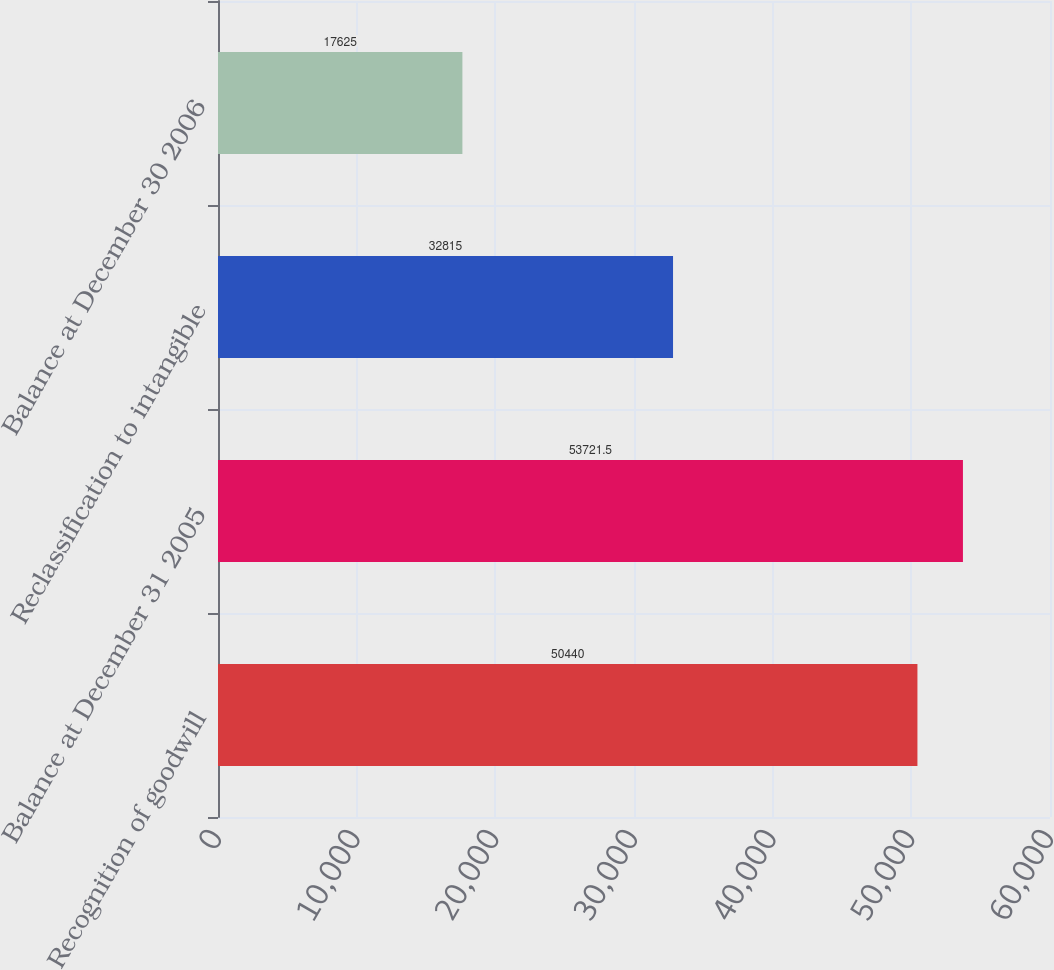<chart> <loc_0><loc_0><loc_500><loc_500><bar_chart><fcel>Recognition of goodwill<fcel>Balance at December 31 2005<fcel>Reclassification to intangible<fcel>Balance at December 30 2006<nl><fcel>50440<fcel>53721.5<fcel>32815<fcel>17625<nl></chart> 